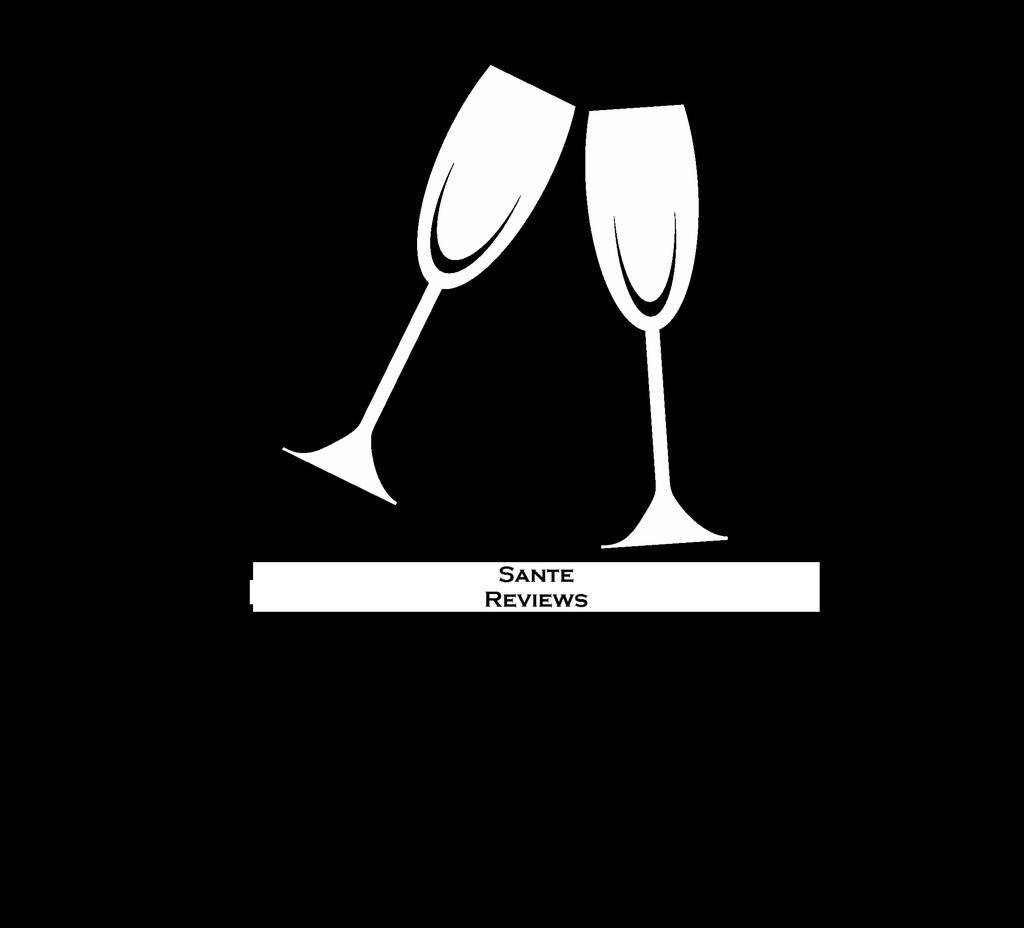Could you give a brief overview of what you see in this image? In this picture I can see graphical images of glasses and I can see text under the glasses. 